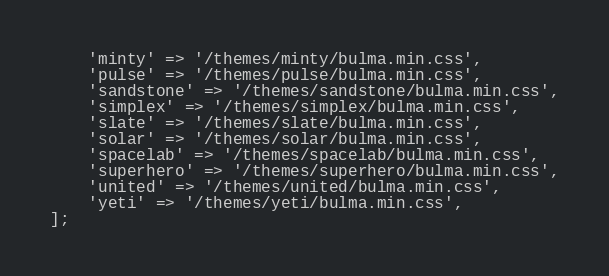<code> <loc_0><loc_0><loc_500><loc_500><_PHP_>    'minty' => '/themes/minty/bulma.min.css',
    'pulse' => '/themes/pulse/bulma.min.css',
    'sandstone' => '/themes/sandstone/bulma.min.css',
    'simplex' => '/themes/simplex/bulma.min.css',
    'slate' => '/themes/slate/bulma.min.css',
    'solar' => '/themes/solar/bulma.min.css',
    'spacelab' => '/themes/spacelab/bulma.min.css',
    'superhero' => '/themes/superhero/bulma.min.css',
    'united' => '/themes/united/bulma.min.css',
    'yeti' => '/themes/yeti/bulma.min.css',
];
</code> 